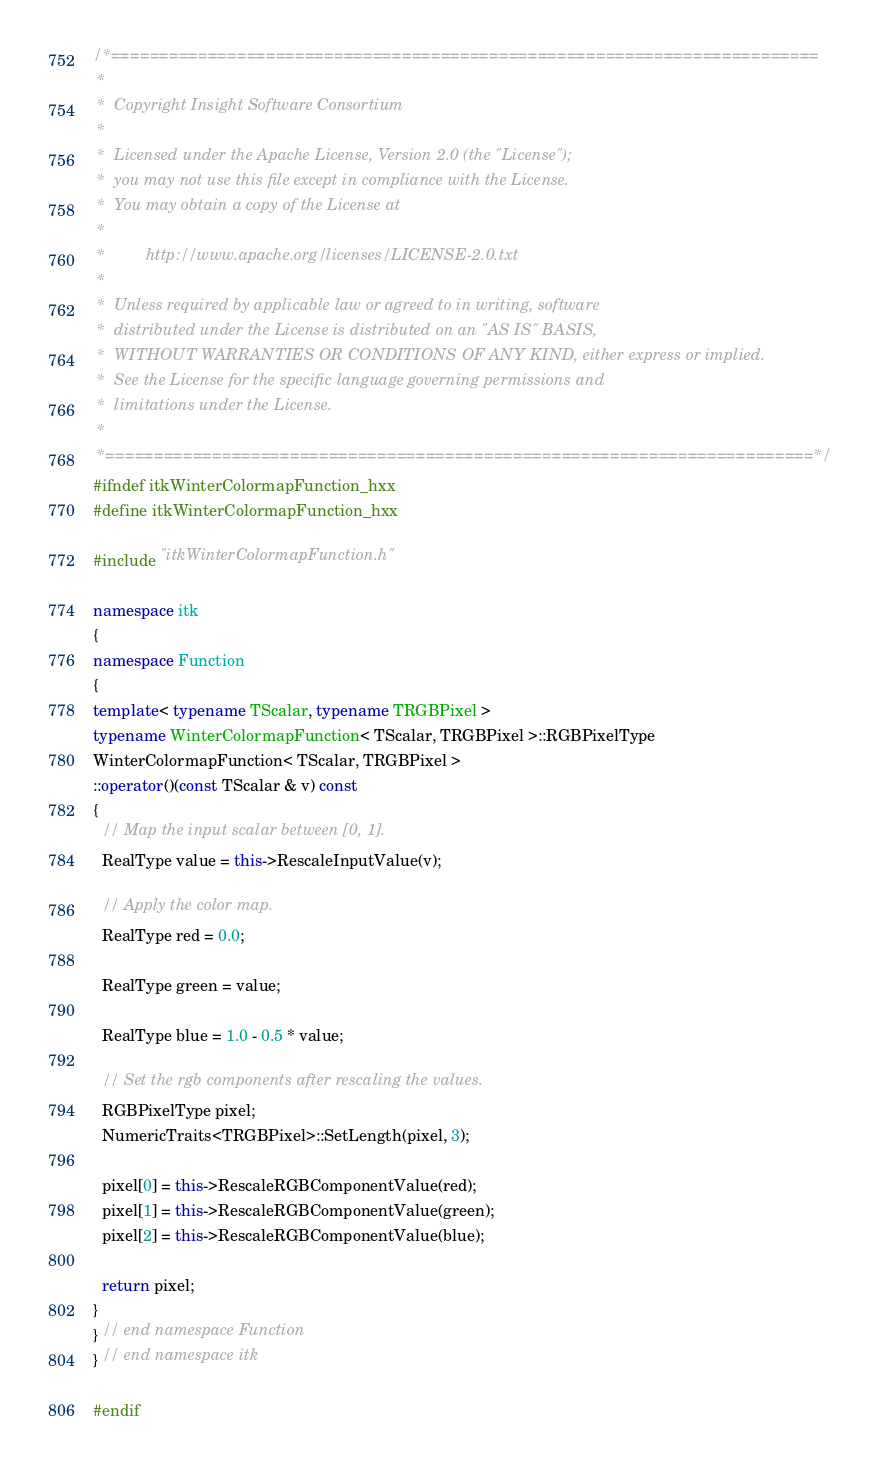Convert code to text. <code><loc_0><loc_0><loc_500><loc_500><_C++_>/*=========================================================================
 *
 *  Copyright Insight Software Consortium
 *
 *  Licensed under the Apache License, Version 2.0 (the "License");
 *  you may not use this file except in compliance with the License.
 *  You may obtain a copy of the License at
 *
 *         http://www.apache.org/licenses/LICENSE-2.0.txt
 *
 *  Unless required by applicable law or agreed to in writing, software
 *  distributed under the License is distributed on an "AS IS" BASIS,
 *  WITHOUT WARRANTIES OR CONDITIONS OF ANY KIND, either express or implied.
 *  See the License for the specific language governing permissions and
 *  limitations under the License.
 *
 *=========================================================================*/
#ifndef itkWinterColormapFunction_hxx
#define itkWinterColormapFunction_hxx

#include "itkWinterColormapFunction.h"

namespace itk
{
namespace Function
{
template< typename TScalar, typename TRGBPixel >
typename WinterColormapFunction< TScalar, TRGBPixel >::RGBPixelType
WinterColormapFunction< TScalar, TRGBPixel >
::operator()(const TScalar & v) const
{
  // Map the input scalar between [0, 1].
  RealType value = this->RescaleInputValue(v);

  // Apply the color map.
  RealType red = 0.0;

  RealType green = value;

  RealType blue = 1.0 - 0.5 * value;

  // Set the rgb components after rescaling the values.
  RGBPixelType pixel;
  NumericTraits<TRGBPixel>::SetLength(pixel, 3);

  pixel[0] = this->RescaleRGBComponentValue(red);
  pixel[1] = this->RescaleRGBComponentValue(green);
  pixel[2] = this->RescaleRGBComponentValue(blue);

  return pixel;
}
} // end namespace Function
} // end namespace itk

#endif
</code> 